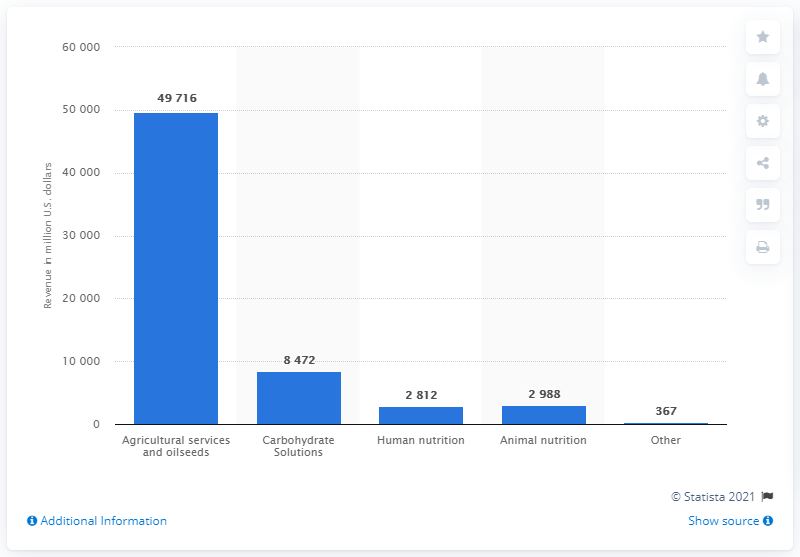Identify some key points in this picture. The animal nutrition segment generated a revenue of 2,988 in 2020. 